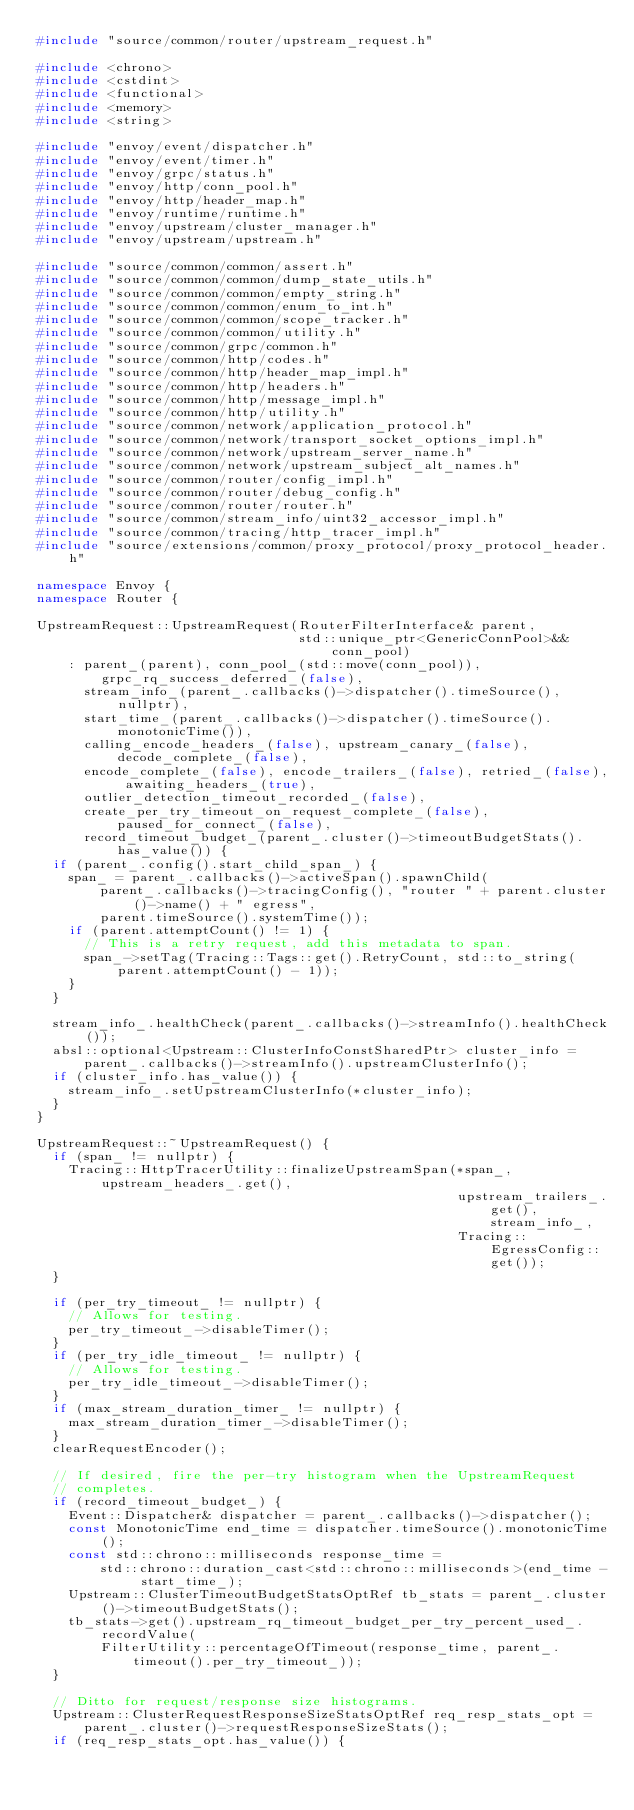Convert code to text. <code><loc_0><loc_0><loc_500><loc_500><_C++_>#include "source/common/router/upstream_request.h"

#include <chrono>
#include <cstdint>
#include <functional>
#include <memory>
#include <string>

#include "envoy/event/dispatcher.h"
#include "envoy/event/timer.h"
#include "envoy/grpc/status.h"
#include "envoy/http/conn_pool.h"
#include "envoy/http/header_map.h"
#include "envoy/runtime/runtime.h"
#include "envoy/upstream/cluster_manager.h"
#include "envoy/upstream/upstream.h"

#include "source/common/common/assert.h"
#include "source/common/common/dump_state_utils.h"
#include "source/common/common/empty_string.h"
#include "source/common/common/enum_to_int.h"
#include "source/common/common/scope_tracker.h"
#include "source/common/common/utility.h"
#include "source/common/grpc/common.h"
#include "source/common/http/codes.h"
#include "source/common/http/header_map_impl.h"
#include "source/common/http/headers.h"
#include "source/common/http/message_impl.h"
#include "source/common/http/utility.h"
#include "source/common/network/application_protocol.h"
#include "source/common/network/transport_socket_options_impl.h"
#include "source/common/network/upstream_server_name.h"
#include "source/common/network/upstream_subject_alt_names.h"
#include "source/common/router/config_impl.h"
#include "source/common/router/debug_config.h"
#include "source/common/router/router.h"
#include "source/common/stream_info/uint32_accessor_impl.h"
#include "source/common/tracing/http_tracer_impl.h"
#include "source/extensions/common/proxy_protocol/proxy_protocol_header.h"

namespace Envoy {
namespace Router {

UpstreamRequest::UpstreamRequest(RouterFilterInterface& parent,
                                 std::unique_ptr<GenericConnPool>&& conn_pool)
    : parent_(parent), conn_pool_(std::move(conn_pool)), grpc_rq_success_deferred_(false),
      stream_info_(parent_.callbacks()->dispatcher().timeSource(), nullptr),
      start_time_(parent_.callbacks()->dispatcher().timeSource().monotonicTime()),
      calling_encode_headers_(false), upstream_canary_(false), decode_complete_(false),
      encode_complete_(false), encode_trailers_(false), retried_(false), awaiting_headers_(true),
      outlier_detection_timeout_recorded_(false),
      create_per_try_timeout_on_request_complete_(false), paused_for_connect_(false),
      record_timeout_budget_(parent_.cluster()->timeoutBudgetStats().has_value()) {
  if (parent_.config().start_child_span_) {
    span_ = parent_.callbacks()->activeSpan().spawnChild(
        parent_.callbacks()->tracingConfig(), "router " + parent.cluster()->name() + " egress",
        parent.timeSource().systemTime());
    if (parent.attemptCount() != 1) {
      // This is a retry request, add this metadata to span.
      span_->setTag(Tracing::Tags::get().RetryCount, std::to_string(parent.attemptCount() - 1));
    }
  }

  stream_info_.healthCheck(parent_.callbacks()->streamInfo().healthCheck());
  absl::optional<Upstream::ClusterInfoConstSharedPtr> cluster_info =
      parent_.callbacks()->streamInfo().upstreamClusterInfo();
  if (cluster_info.has_value()) {
    stream_info_.setUpstreamClusterInfo(*cluster_info);
  }
}

UpstreamRequest::~UpstreamRequest() {
  if (span_ != nullptr) {
    Tracing::HttpTracerUtility::finalizeUpstreamSpan(*span_, upstream_headers_.get(),
                                                     upstream_trailers_.get(), stream_info_,
                                                     Tracing::EgressConfig::get());
  }

  if (per_try_timeout_ != nullptr) {
    // Allows for testing.
    per_try_timeout_->disableTimer();
  }
  if (per_try_idle_timeout_ != nullptr) {
    // Allows for testing.
    per_try_idle_timeout_->disableTimer();
  }
  if (max_stream_duration_timer_ != nullptr) {
    max_stream_duration_timer_->disableTimer();
  }
  clearRequestEncoder();

  // If desired, fire the per-try histogram when the UpstreamRequest
  // completes.
  if (record_timeout_budget_) {
    Event::Dispatcher& dispatcher = parent_.callbacks()->dispatcher();
    const MonotonicTime end_time = dispatcher.timeSource().monotonicTime();
    const std::chrono::milliseconds response_time =
        std::chrono::duration_cast<std::chrono::milliseconds>(end_time - start_time_);
    Upstream::ClusterTimeoutBudgetStatsOptRef tb_stats = parent_.cluster()->timeoutBudgetStats();
    tb_stats->get().upstream_rq_timeout_budget_per_try_percent_used_.recordValue(
        FilterUtility::percentageOfTimeout(response_time, parent_.timeout().per_try_timeout_));
  }

  // Ditto for request/response size histograms.
  Upstream::ClusterRequestResponseSizeStatsOptRef req_resp_stats_opt =
      parent_.cluster()->requestResponseSizeStats();
  if (req_resp_stats_opt.has_value()) {</code> 